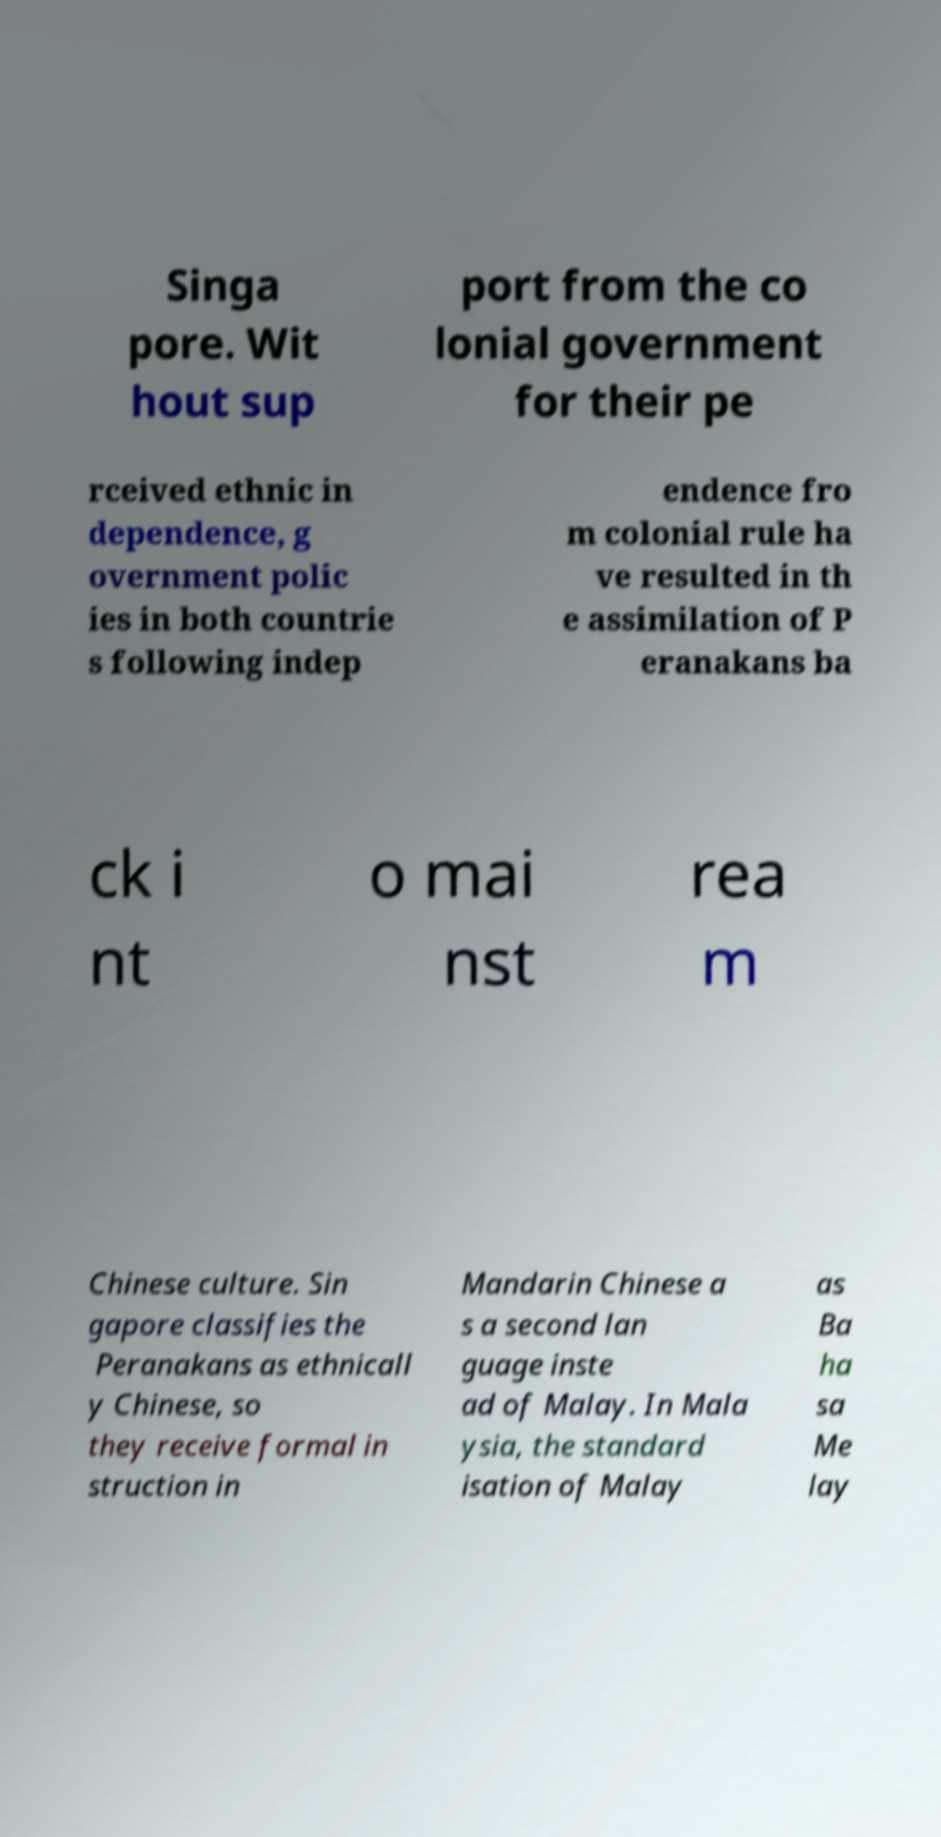There's text embedded in this image that I need extracted. Can you transcribe it verbatim? Singa pore. Wit hout sup port from the co lonial government for their pe rceived ethnic in dependence, g overnment polic ies in both countrie s following indep endence fro m colonial rule ha ve resulted in th e assimilation of P eranakans ba ck i nt o mai nst rea m Chinese culture. Sin gapore classifies the Peranakans as ethnicall y Chinese, so they receive formal in struction in Mandarin Chinese a s a second lan guage inste ad of Malay. In Mala ysia, the standard isation of Malay as Ba ha sa Me lay 